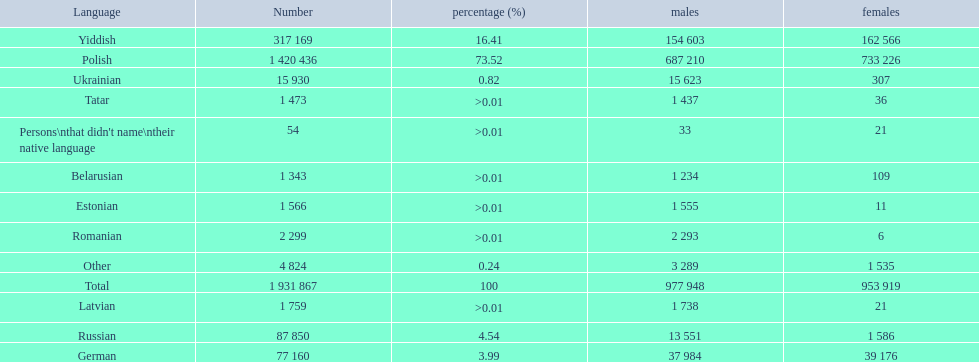What is the percentage of polish speakers? 73.52. What is the next highest percentage of speakers? 16.41. What language is this percentage? Yiddish. 